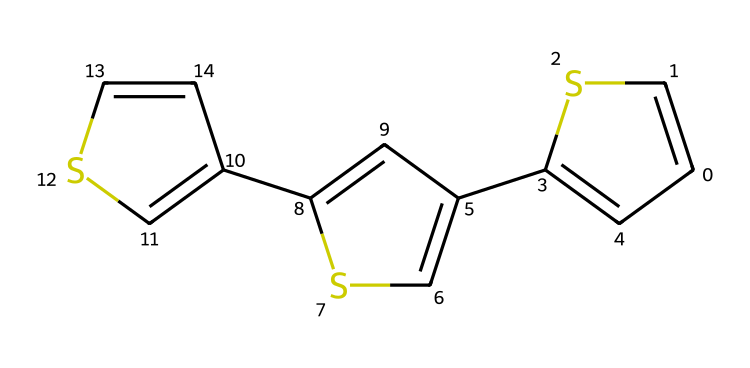What is the molecular formula of this compound? To derive the molecular formula, we need to count the number of each type of atom present in the chemical structure. The structure given shows a total of 12 carbon atoms and 6 sulfur atoms based on the SMILES representation. Therefore, the molecular formula is constructed as C12S6.
Answer: C12S6 How many rings are present in this structure? The SMILES representation shows three distinct cyclic parts (C1, C2, C3) indicating the presence of three rings in the structure. Each ring can be identified by the numbers in the SMILES notation that denote the start and end of the cyclic structures.
Answer: 3 What type of polymer does this structure represent? Given the heterocyclic components including sulfur atoms, this chemical structure is indicative of a conductive polymer known as poly(thiophene). The presence of alternating double bonds and sulfur atoms contributes to its conductivity.
Answer: poly(thiophene) How does the presence of sulfur affect the conductivity of this polymer? The sulfur atoms in the cyclic structure facilitate the delocalization of π-electrons across the polymer chain, enhancing electrical conductivity. This delocalization allows for easier charge transfer along the polymer backbone, significantly affecting its conductive properties.
Answer: enhances conductivity What is the significance of the conjugated system in this polymer? The conjugated double bond system formed by the alternating single and double bonds in the structure allows for electron delocalization, which is crucial for the polymer's electrical properties. This arrangement leads to increased stability and conductivity, which makes it suitable for applications in flexible electronics.
Answer: crucial for conductivity 